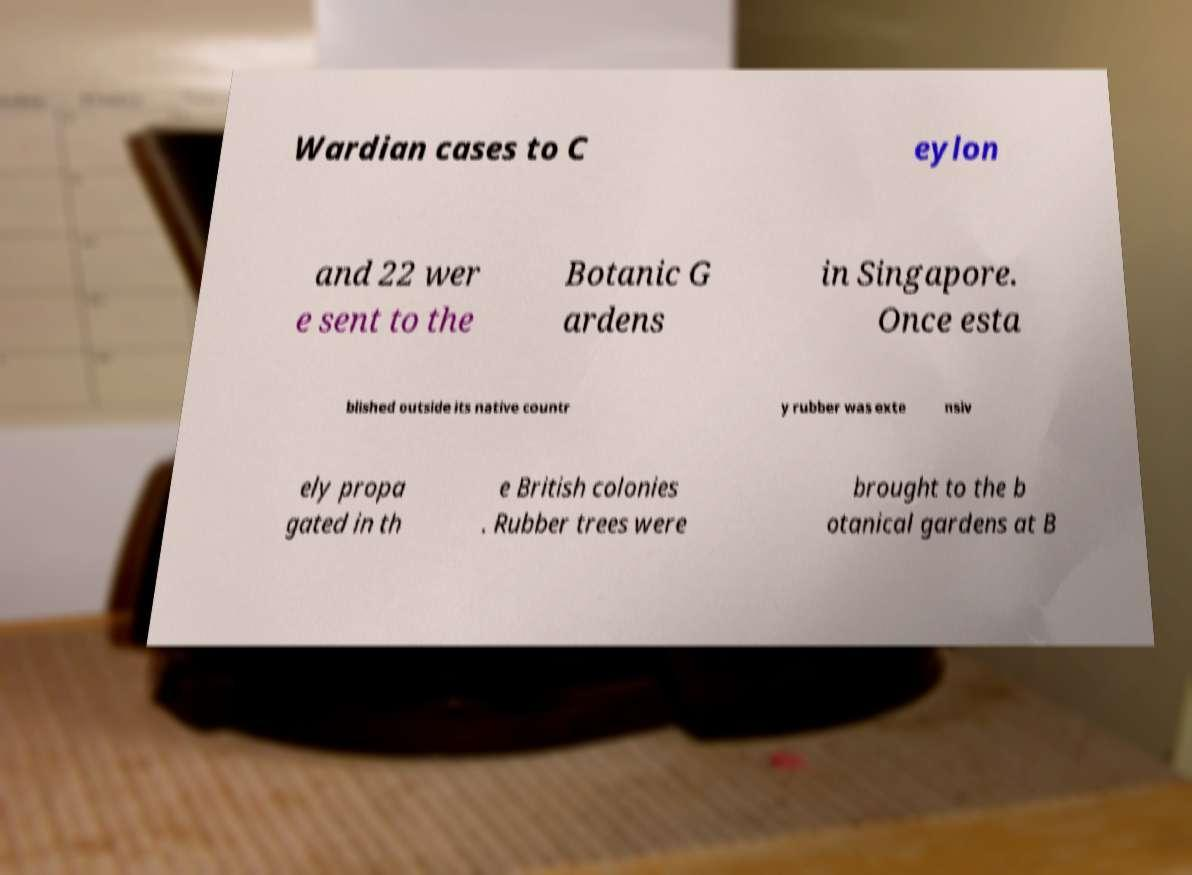There's text embedded in this image that I need extracted. Can you transcribe it verbatim? Wardian cases to C eylon and 22 wer e sent to the Botanic G ardens in Singapore. Once esta blished outside its native countr y rubber was exte nsiv ely propa gated in th e British colonies . Rubber trees were brought to the b otanical gardens at B 